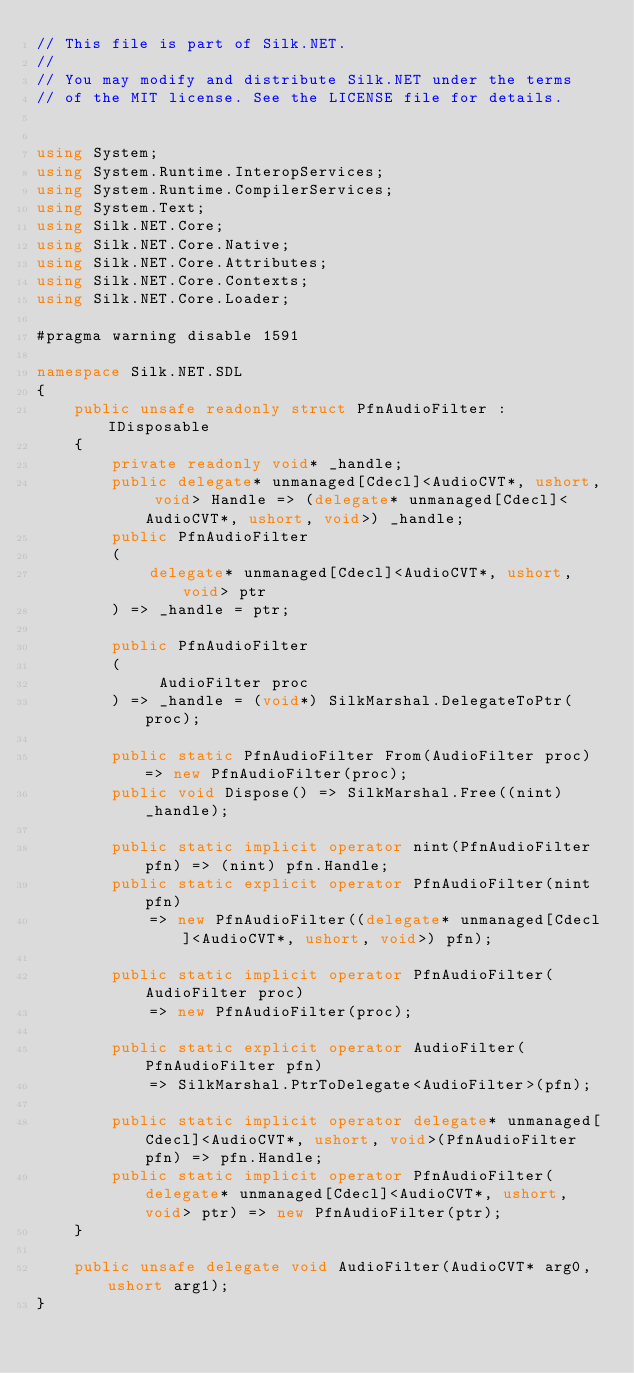<code> <loc_0><loc_0><loc_500><loc_500><_C#_>// This file is part of Silk.NET.
// 
// You may modify and distribute Silk.NET under the terms
// of the MIT license. See the LICENSE file for details.


using System;
using System.Runtime.InteropServices;
using System.Runtime.CompilerServices;
using System.Text;
using Silk.NET.Core;
using Silk.NET.Core.Native;
using Silk.NET.Core.Attributes;
using Silk.NET.Core.Contexts;
using Silk.NET.Core.Loader;

#pragma warning disable 1591

namespace Silk.NET.SDL
{
    public unsafe readonly struct PfnAudioFilter : IDisposable
    {
        private readonly void* _handle;
        public delegate* unmanaged[Cdecl]<AudioCVT*, ushort, void> Handle => (delegate* unmanaged[Cdecl]<AudioCVT*, ushort, void>) _handle;
        public PfnAudioFilter
        (
            delegate* unmanaged[Cdecl]<AudioCVT*, ushort, void> ptr
        ) => _handle = ptr;

        public PfnAudioFilter
        (
             AudioFilter proc
        ) => _handle = (void*) SilkMarshal.DelegateToPtr(proc);

        public static PfnAudioFilter From(AudioFilter proc) => new PfnAudioFilter(proc);
        public void Dispose() => SilkMarshal.Free((nint) _handle);

        public static implicit operator nint(PfnAudioFilter pfn) => (nint) pfn.Handle;
        public static explicit operator PfnAudioFilter(nint pfn)
            => new PfnAudioFilter((delegate* unmanaged[Cdecl]<AudioCVT*, ushort, void>) pfn);

        public static implicit operator PfnAudioFilter(AudioFilter proc)
            => new PfnAudioFilter(proc);

        public static explicit operator AudioFilter(PfnAudioFilter pfn)
            => SilkMarshal.PtrToDelegate<AudioFilter>(pfn);

        public static implicit operator delegate* unmanaged[Cdecl]<AudioCVT*, ushort, void>(PfnAudioFilter pfn) => pfn.Handle;
        public static implicit operator PfnAudioFilter(delegate* unmanaged[Cdecl]<AudioCVT*, ushort, void> ptr) => new PfnAudioFilter(ptr);
    }

    public unsafe delegate void AudioFilter(AudioCVT* arg0, ushort arg1);
}

</code> 